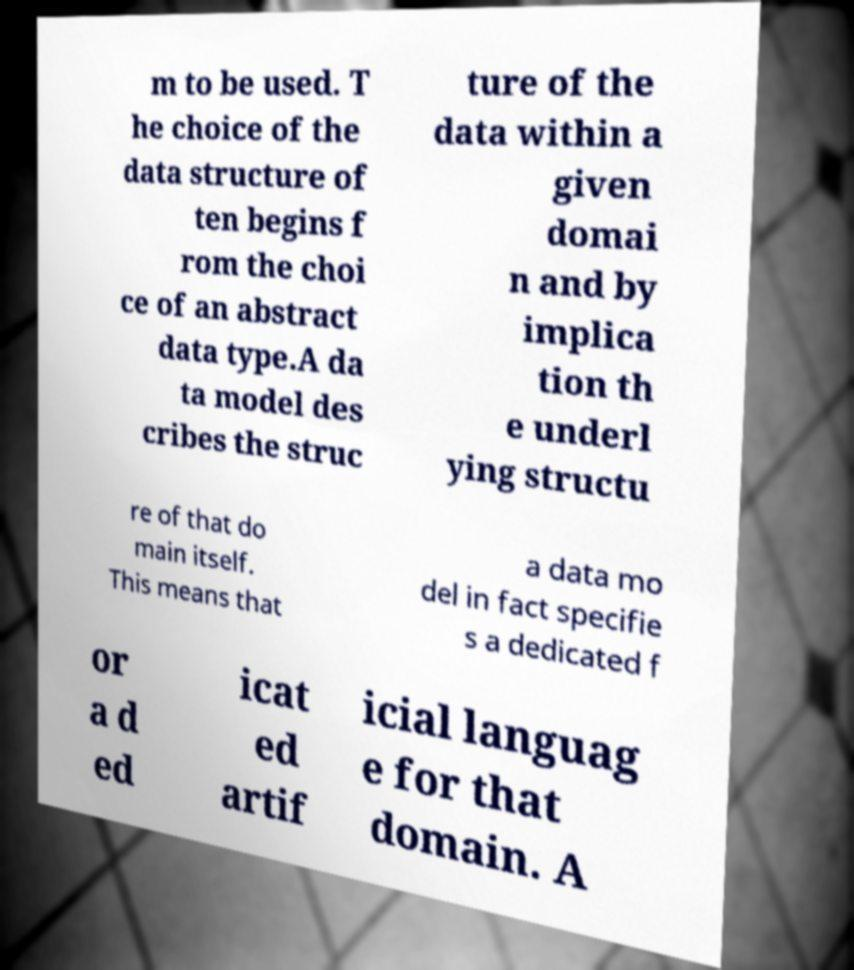Can you accurately transcribe the text from the provided image for me? m to be used. T he choice of the data structure of ten begins f rom the choi ce of an abstract data type.A da ta model des cribes the struc ture of the data within a given domai n and by implica tion th e underl ying structu re of that do main itself. This means that a data mo del in fact specifie s a dedicated f or a d ed icat ed artif icial languag e for that domain. A 